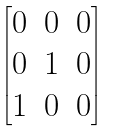Convert formula to latex. <formula><loc_0><loc_0><loc_500><loc_500>\begin{bmatrix} 0 & 0 & 0 \\ 0 & 1 & 0 \\ 1 & 0 & 0 \end{bmatrix}</formula> 